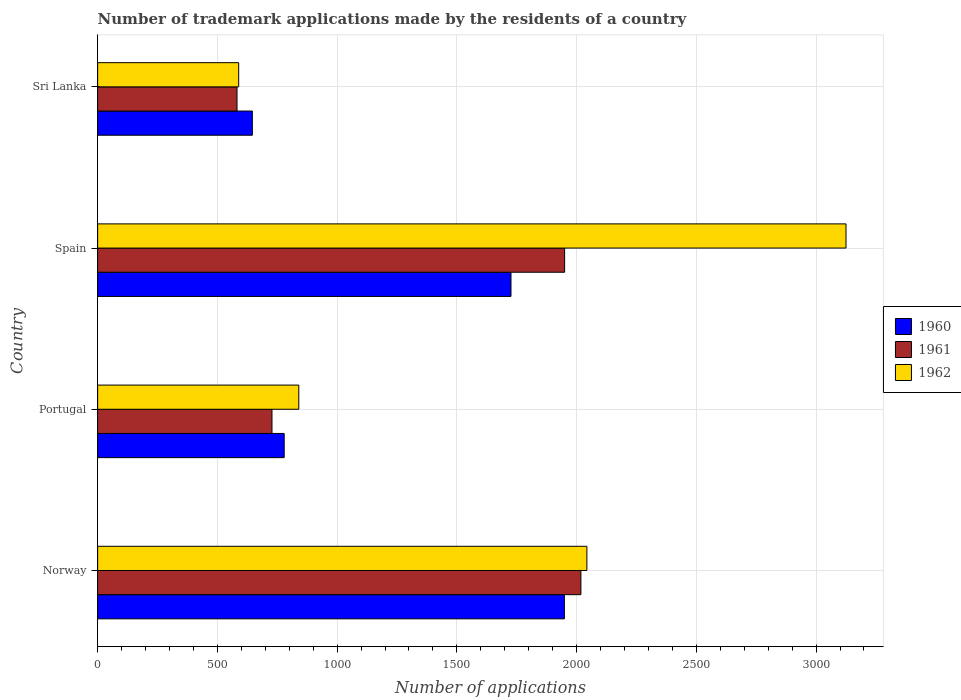How many different coloured bars are there?
Your response must be concise. 3. Are the number of bars per tick equal to the number of legend labels?
Your answer should be compact. Yes. What is the label of the 2nd group of bars from the top?
Make the answer very short. Spain. In how many cases, is the number of bars for a given country not equal to the number of legend labels?
Provide a succinct answer. 0. What is the number of trademark applications made by the residents in 1962 in Sri Lanka?
Provide a short and direct response. 589. Across all countries, what is the maximum number of trademark applications made by the residents in 1962?
Keep it short and to the point. 3125. Across all countries, what is the minimum number of trademark applications made by the residents in 1960?
Provide a succinct answer. 646. In which country was the number of trademark applications made by the residents in 1960 maximum?
Offer a terse response. Norway. In which country was the number of trademark applications made by the residents in 1962 minimum?
Ensure brevity in your answer.  Sri Lanka. What is the total number of trademark applications made by the residents in 1960 in the graph?
Your answer should be compact. 5100. What is the difference between the number of trademark applications made by the residents in 1962 in Portugal and that in Spain?
Make the answer very short. -2285. What is the difference between the number of trademark applications made by the residents in 1962 in Sri Lanka and the number of trademark applications made by the residents in 1960 in Spain?
Offer a terse response. -1137. What is the average number of trademark applications made by the residents in 1960 per country?
Give a very brief answer. 1275. What is the difference between the number of trademark applications made by the residents in 1962 and number of trademark applications made by the residents in 1960 in Spain?
Provide a succinct answer. 1399. What is the ratio of the number of trademark applications made by the residents in 1962 in Spain to that in Sri Lanka?
Offer a very short reply. 5.31. What is the difference between the highest and the second highest number of trademark applications made by the residents in 1960?
Offer a terse response. 223. What is the difference between the highest and the lowest number of trademark applications made by the residents in 1960?
Give a very brief answer. 1303. In how many countries, is the number of trademark applications made by the residents in 1960 greater than the average number of trademark applications made by the residents in 1960 taken over all countries?
Offer a very short reply. 2. Is the sum of the number of trademark applications made by the residents in 1962 in Portugal and Spain greater than the maximum number of trademark applications made by the residents in 1960 across all countries?
Your answer should be very brief. Yes. What does the 1st bar from the top in Spain represents?
Ensure brevity in your answer.  1962. What does the 2nd bar from the bottom in Sri Lanka represents?
Your answer should be compact. 1961. Is it the case that in every country, the sum of the number of trademark applications made by the residents in 1960 and number of trademark applications made by the residents in 1962 is greater than the number of trademark applications made by the residents in 1961?
Your answer should be compact. Yes. How many countries are there in the graph?
Offer a very short reply. 4. Are the values on the major ticks of X-axis written in scientific E-notation?
Your answer should be very brief. No. Does the graph contain any zero values?
Offer a terse response. No. Where does the legend appear in the graph?
Offer a terse response. Center right. What is the title of the graph?
Your answer should be very brief. Number of trademark applications made by the residents of a country. Does "2005" appear as one of the legend labels in the graph?
Give a very brief answer. No. What is the label or title of the X-axis?
Offer a very short reply. Number of applications. What is the label or title of the Y-axis?
Provide a short and direct response. Country. What is the Number of applications in 1960 in Norway?
Keep it short and to the point. 1949. What is the Number of applications in 1961 in Norway?
Offer a very short reply. 2018. What is the Number of applications of 1962 in Norway?
Keep it short and to the point. 2043. What is the Number of applications in 1960 in Portugal?
Provide a short and direct response. 779. What is the Number of applications of 1961 in Portugal?
Your response must be concise. 728. What is the Number of applications of 1962 in Portugal?
Keep it short and to the point. 840. What is the Number of applications of 1960 in Spain?
Your answer should be very brief. 1726. What is the Number of applications in 1961 in Spain?
Make the answer very short. 1950. What is the Number of applications in 1962 in Spain?
Keep it short and to the point. 3125. What is the Number of applications of 1960 in Sri Lanka?
Offer a terse response. 646. What is the Number of applications in 1961 in Sri Lanka?
Make the answer very short. 582. What is the Number of applications of 1962 in Sri Lanka?
Your answer should be compact. 589. Across all countries, what is the maximum Number of applications in 1960?
Provide a succinct answer. 1949. Across all countries, what is the maximum Number of applications of 1961?
Provide a short and direct response. 2018. Across all countries, what is the maximum Number of applications of 1962?
Give a very brief answer. 3125. Across all countries, what is the minimum Number of applications in 1960?
Keep it short and to the point. 646. Across all countries, what is the minimum Number of applications of 1961?
Keep it short and to the point. 582. Across all countries, what is the minimum Number of applications of 1962?
Offer a very short reply. 589. What is the total Number of applications in 1960 in the graph?
Ensure brevity in your answer.  5100. What is the total Number of applications of 1961 in the graph?
Your answer should be very brief. 5278. What is the total Number of applications in 1962 in the graph?
Your answer should be very brief. 6597. What is the difference between the Number of applications in 1960 in Norway and that in Portugal?
Make the answer very short. 1170. What is the difference between the Number of applications in 1961 in Norway and that in Portugal?
Offer a terse response. 1290. What is the difference between the Number of applications in 1962 in Norway and that in Portugal?
Your answer should be compact. 1203. What is the difference between the Number of applications in 1960 in Norway and that in Spain?
Your answer should be compact. 223. What is the difference between the Number of applications of 1961 in Norway and that in Spain?
Your answer should be very brief. 68. What is the difference between the Number of applications of 1962 in Norway and that in Spain?
Your response must be concise. -1082. What is the difference between the Number of applications of 1960 in Norway and that in Sri Lanka?
Keep it short and to the point. 1303. What is the difference between the Number of applications in 1961 in Norway and that in Sri Lanka?
Provide a short and direct response. 1436. What is the difference between the Number of applications of 1962 in Norway and that in Sri Lanka?
Make the answer very short. 1454. What is the difference between the Number of applications of 1960 in Portugal and that in Spain?
Offer a very short reply. -947. What is the difference between the Number of applications of 1961 in Portugal and that in Spain?
Keep it short and to the point. -1222. What is the difference between the Number of applications in 1962 in Portugal and that in Spain?
Make the answer very short. -2285. What is the difference between the Number of applications in 1960 in Portugal and that in Sri Lanka?
Provide a succinct answer. 133. What is the difference between the Number of applications of 1961 in Portugal and that in Sri Lanka?
Your response must be concise. 146. What is the difference between the Number of applications in 1962 in Portugal and that in Sri Lanka?
Provide a short and direct response. 251. What is the difference between the Number of applications of 1960 in Spain and that in Sri Lanka?
Ensure brevity in your answer.  1080. What is the difference between the Number of applications in 1961 in Spain and that in Sri Lanka?
Make the answer very short. 1368. What is the difference between the Number of applications of 1962 in Spain and that in Sri Lanka?
Offer a terse response. 2536. What is the difference between the Number of applications of 1960 in Norway and the Number of applications of 1961 in Portugal?
Your response must be concise. 1221. What is the difference between the Number of applications in 1960 in Norway and the Number of applications in 1962 in Portugal?
Make the answer very short. 1109. What is the difference between the Number of applications of 1961 in Norway and the Number of applications of 1962 in Portugal?
Offer a very short reply. 1178. What is the difference between the Number of applications of 1960 in Norway and the Number of applications of 1961 in Spain?
Offer a terse response. -1. What is the difference between the Number of applications in 1960 in Norway and the Number of applications in 1962 in Spain?
Make the answer very short. -1176. What is the difference between the Number of applications of 1961 in Norway and the Number of applications of 1962 in Spain?
Make the answer very short. -1107. What is the difference between the Number of applications of 1960 in Norway and the Number of applications of 1961 in Sri Lanka?
Your answer should be compact. 1367. What is the difference between the Number of applications of 1960 in Norway and the Number of applications of 1962 in Sri Lanka?
Your response must be concise. 1360. What is the difference between the Number of applications of 1961 in Norway and the Number of applications of 1962 in Sri Lanka?
Provide a short and direct response. 1429. What is the difference between the Number of applications in 1960 in Portugal and the Number of applications in 1961 in Spain?
Provide a succinct answer. -1171. What is the difference between the Number of applications of 1960 in Portugal and the Number of applications of 1962 in Spain?
Your response must be concise. -2346. What is the difference between the Number of applications in 1961 in Portugal and the Number of applications in 1962 in Spain?
Make the answer very short. -2397. What is the difference between the Number of applications in 1960 in Portugal and the Number of applications in 1961 in Sri Lanka?
Ensure brevity in your answer.  197. What is the difference between the Number of applications of 1960 in Portugal and the Number of applications of 1962 in Sri Lanka?
Keep it short and to the point. 190. What is the difference between the Number of applications in 1961 in Portugal and the Number of applications in 1962 in Sri Lanka?
Your answer should be very brief. 139. What is the difference between the Number of applications in 1960 in Spain and the Number of applications in 1961 in Sri Lanka?
Your answer should be compact. 1144. What is the difference between the Number of applications in 1960 in Spain and the Number of applications in 1962 in Sri Lanka?
Make the answer very short. 1137. What is the difference between the Number of applications in 1961 in Spain and the Number of applications in 1962 in Sri Lanka?
Keep it short and to the point. 1361. What is the average Number of applications of 1960 per country?
Give a very brief answer. 1275. What is the average Number of applications of 1961 per country?
Your response must be concise. 1319.5. What is the average Number of applications of 1962 per country?
Ensure brevity in your answer.  1649.25. What is the difference between the Number of applications of 1960 and Number of applications of 1961 in Norway?
Offer a terse response. -69. What is the difference between the Number of applications of 1960 and Number of applications of 1962 in Norway?
Make the answer very short. -94. What is the difference between the Number of applications of 1961 and Number of applications of 1962 in Norway?
Give a very brief answer. -25. What is the difference between the Number of applications in 1960 and Number of applications in 1962 in Portugal?
Keep it short and to the point. -61. What is the difference between the Number of applications in 1961 and Number of applications in 1962 in Portugal?
Ensure brevity in your answer.  -112. What is the difference between the Number of applications of 1960 and Number of applications of 1961 in Spain?
Offer a terse response. -224. What is the difference between the Number of applications in 1960 and Number of applications in 1962 in Spain?
Your answer should be very brief. -1399. What is the difference between the Number of applications in 1961 and Number of applications in 1962 in Spain?
Offer a terse response. -1175. What is the difference between the Number of applications in 1960 and Number of applications in 1961 in Sri Lanka?
Provide a short and direct response. 64. What is the difference between the Number of applications of 1961 and Number of applications of 1962 in Sri Lanka?
Your response must be concise. -7. What is the ratio of the Number of applications in 1960 in Norway to that in Portugal?
Offer a very short reply. 2.5. What is the ratio of the Number of applications in 1961 in Norway to that in Portugal?
Keep it short and to the point. 2.77. What is the ratio of the Number of applications in 1962 in Norway to that in Portugal?
Provide a short and direct response. 2.43. What is the ratio of the Number of applications in 1960 in Norway to that in Spain?
Give a very brief answer. 1.13. What is the ratio of the Number of applications in 1961 in Norway to that in Spain?
Make the answer very short. 1.03. What is the ratio of the Number of applications in 1962 in Norway to that in Spain?
Make the answer very short. 0.65. What is the ratio of the Number of applications in 1960 in Norway to that in Sri Lanka?
Offer a very short reply. 3.02. What is the ratio of the Number of applications of 1961 in Norway to that in Sri Lanka?
Make the answer very short. 3.47. What is the ratio of the Number of applications in 1962 in Norway to that in Sri Lanka?
Ensure brevity in your answer.  3.47. What is the ratio of the Number of applications in 1960 in Portugal to that in Spain?
Give a very brief answer. 0.45. What is the ratio of the Number of applications in 1961 in Portugal to that in Spain?
Keep it short and to the point. 0.37. What is the ratio of the Number of applications in 1962 in Portugal to that in Spain?
Keep it short and to the point. 0.27. What is the ratio of the Number of applications of 1960 in Portugal to that in Sri Lanka?
Give a very brief answer. 1.21. What is the ratio of the Number of applications of 1961 in Portugal to that in Sri Lanka?
Keep it short and to the point. 1.25. What is the ratio of the Number of applications in 1962 in Portugal to that in Sri Lanka?
Your response must be concise. 1.43. What is the ratio of the Number of applications in 1960 in Spain to that in Sri Lanka?
Your answer should be very brief. 2.67. What is the ratio of the Number of applications in 1961 in Spain to that in Sri Lanka?
Make the answer very short. 3.35. What is the ratio of the Number of applications of 1962 in Spain to that in Sri Lanka?
Give a very brief answer. 5.31. What is the difference between the highest and the second highest Number of applications in 1960?
Make the answer very short. 223. What is the difference between the highest and the second highest Number of applications of 1962?
Offer a very short reply. 1082. What is the difference between the highest and the lowest Number of applications of 1960?
Provide a short and direct response. 1303. What is the difference between the highest and the lowest Number of applications of 1961?
Your response must be concise. 1436. What is the difference between the highest and the lowest Number of applications of 1962?
Your response must be concise. 2536. 